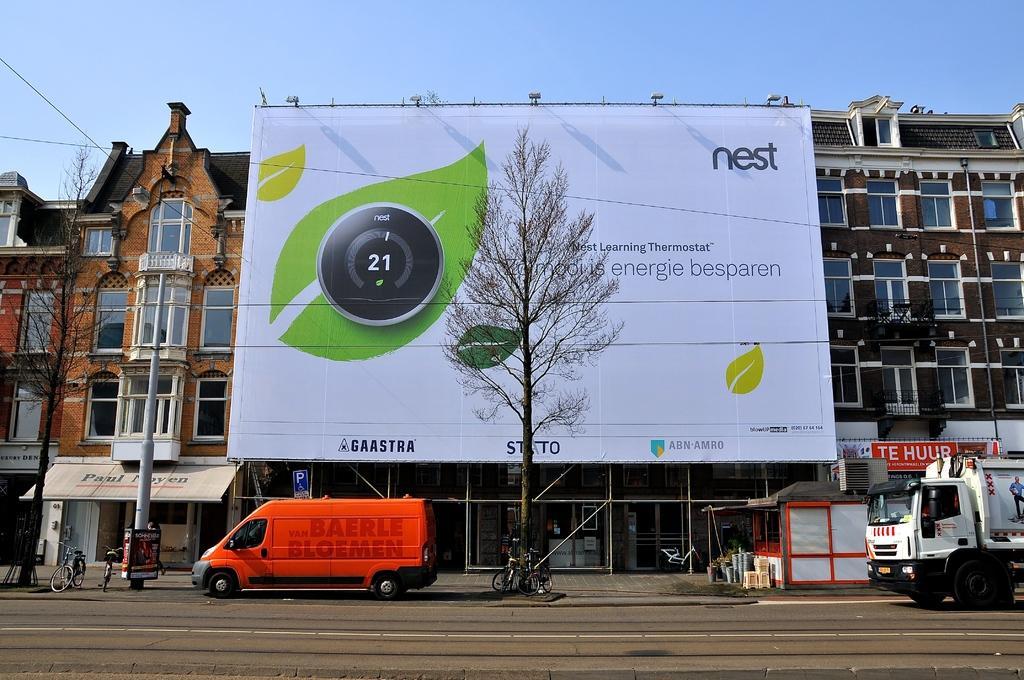How would you summarize this image in a sentence or two? In this image there are vehicles moving on a road, in the background there are cycles on a footpath and there are trees, poles and a building near the building there is a banner, on that banner there is some text and there is the sky. 